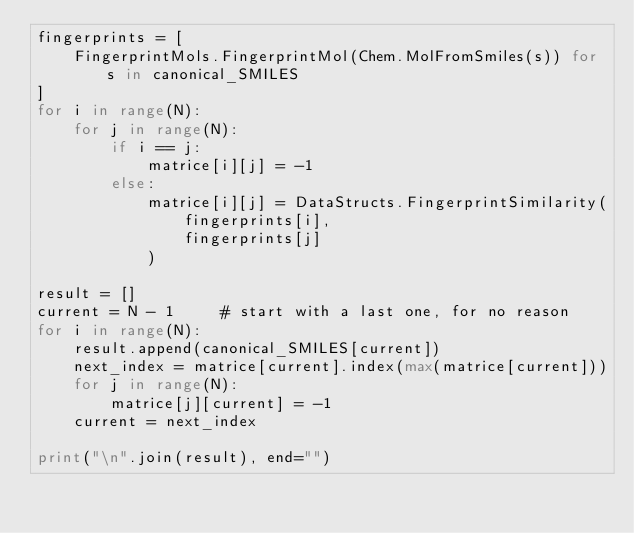Convert code to text. <code><loc_0><loc_0><loc_500><loc_500><_Python_>fingerprints = [
    FingerprintMols.FingerprintMol(Chem.MolFromSmiles(s)) for s in canonical_SMILES
]
for i in range(N):
    for j in range(N):
        if i == j:
            matrice[i][j] = -1
        else:
            matrice[i][j] = DataStructs.FingerprintSimilarity(
                fingerprints[i],
                fingerprints[j]
            )

result = []
current = N - 1     # start with a last one, for no reason
for i in range(N):
    result.append(canonical_SMILES[current])
    next_index = matrice[current].index(max(matrice[current]))
    for j in range(N):
        matrice[j][current] = -1
    current = next_index

print("\n".join(result), end="")
</code> 